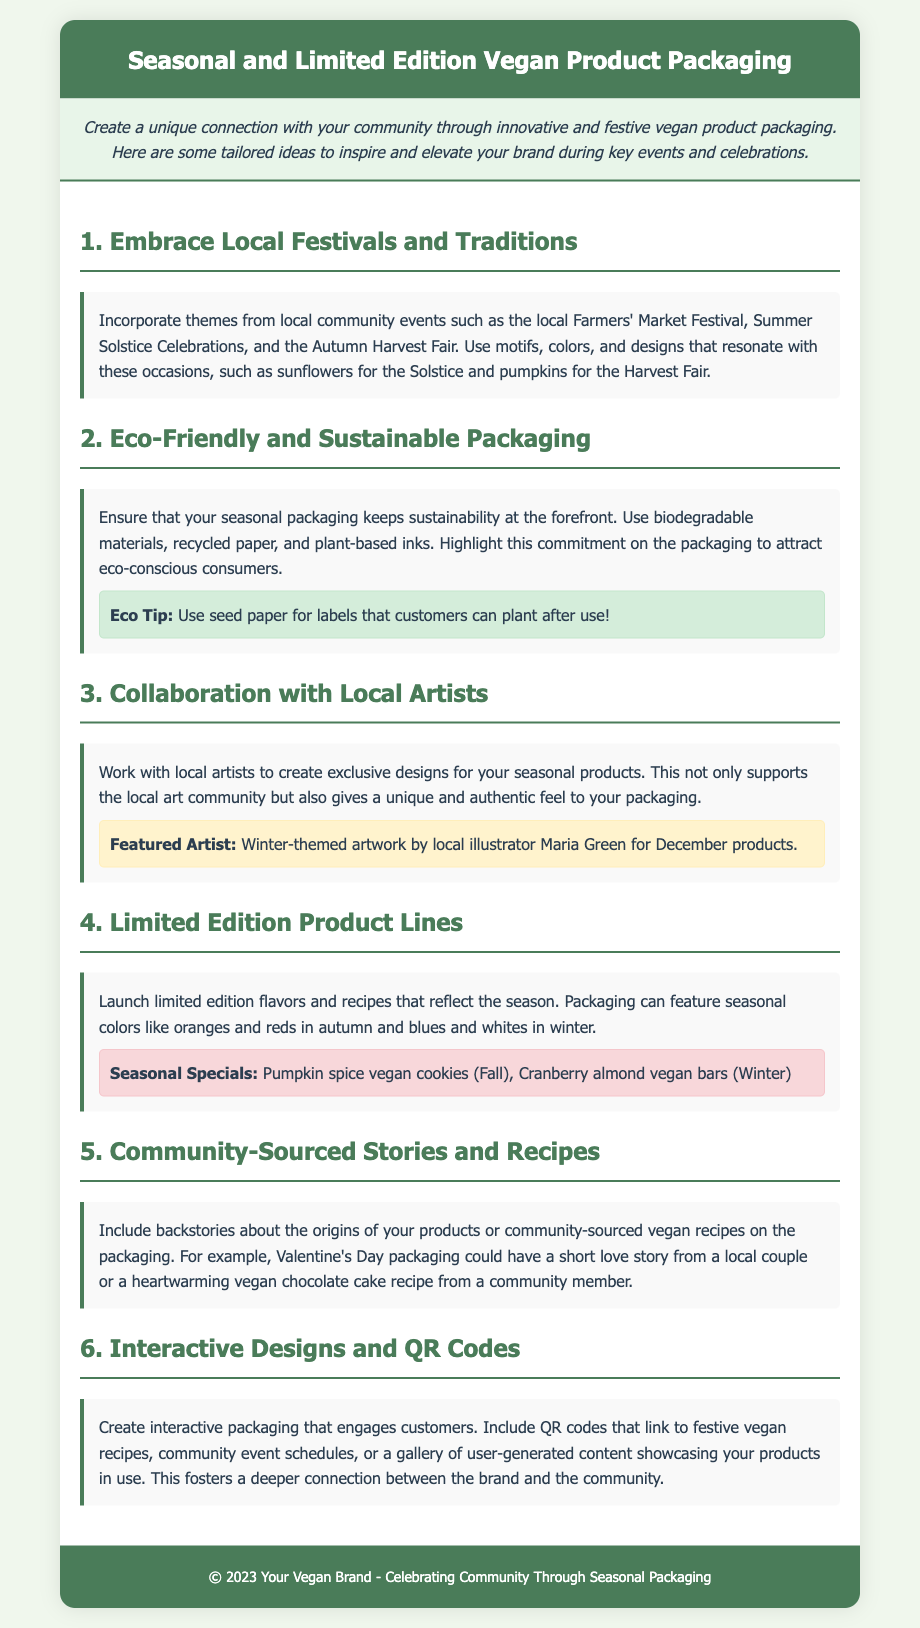What is the title of the document? The title is stated clearly at the top of the document within the header section.
Answer: Seasonal and Limited Edition Vegan Product Packaging What are the seasonal special products mentioned? The document lists specific products under the limited edition section, highlighting their seasonal nature.
Answer: Pumpkin spice vegan cookies, Cranberry almond vegan bars Who is the featured artist for the winter-themed artwork? The document includes a specific name associated with the local artist collaboration.
Answer: Maria Green What eco-friendly tip is provided in the document? The eco-friendly section includes a particular suggestion pertaining to sustainable packaging solutions.
Answer: Use seed paper for labels What community event theme is suggested for the product packaging? The document discusses incorporating themes from local events as a design element in packaging.
Answer: Farmers' Market Festival How many sections are dedicated to product packaging ideas in the document? The sections listing ideas are numbered, providing a clear count of topics addressed.
Answer: Six What type of designs are recommended to engage customers? The document suggests implementing a specific interactive element within the packaging.
Answer: Interactive designs and QR codes What colors are suggested for autumn product packaging? The document describes specific color themes that should be used for different seasonal packaging.
Answer: Oranges and reds What is emphasized regarding sustainability in the packaging? The document underscores a commitment or principle regarding the materials used for packaging.
Answer: Use biodegradable materials 